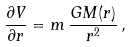<formula> <loc_0><loc_0><loc_500><loc_500>\frac { \partial V } { \partial r } = m \, \frac { G M ( r ) } { r ^ { 2 } } \, ,</formula> 